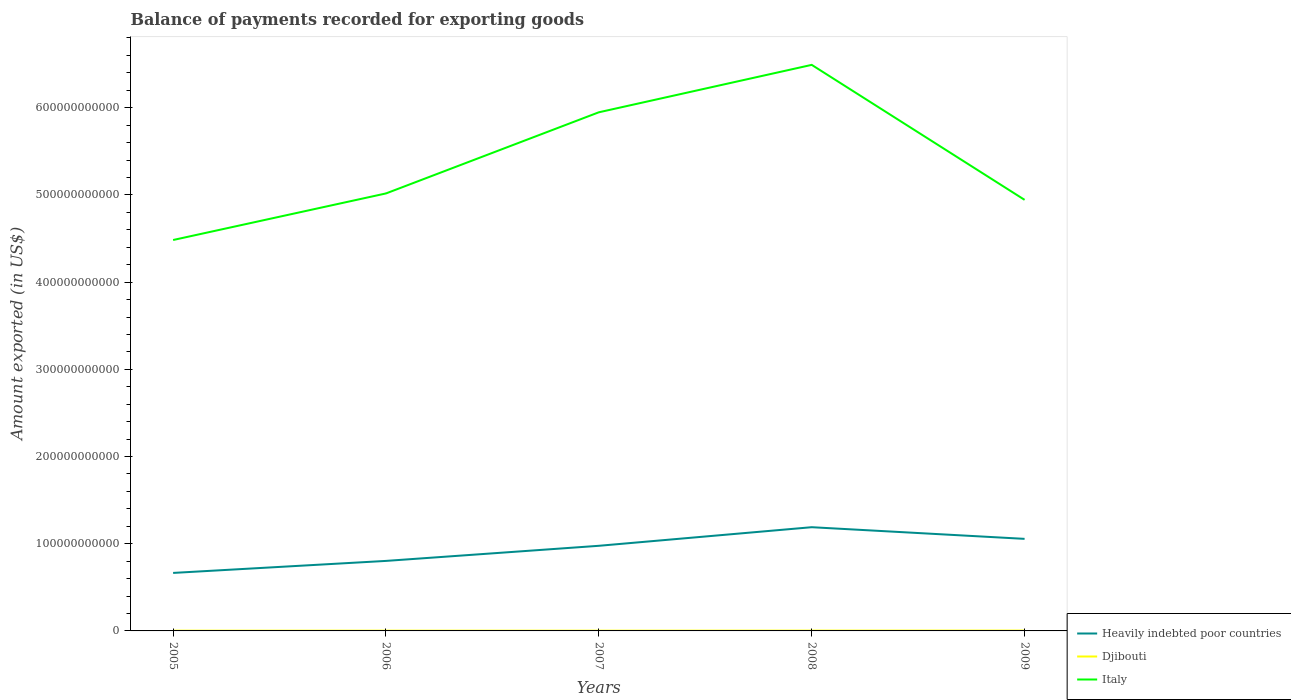Across all years, what is the maximum amount exported in Italy?
Give a very brief answer. 4.48e+11. In which year was the amount exported in Italy maximum?
Keep it short and to the point. 2005. What is the total amount exported in Italy in the graph?
Provide a short and direct response. 1.55e+11. What is the difference between the highest and the second highest amount exported in Italy?
Give a very brief answer. 2.01e+11. What is the difference between the highest and the lowest amount exported in Heavily indebted poor countries?
Keep it short and to the point. 3. Is the amount exported in Djibouti strictly greater than the amount exported in Italy over the years?
Keep it short and to the point. Yes. How many lines are there?
Your answer should be compact. 3. What is the difference between two consecutive major ticks on the Y-axis?
Provide a short and direct response. 1.00e+11. Does the graph contain any zero values?
Give a very brief answer. No. Does the graph contain grids?
Your answer should be very brief. No. Where does the legend appear in the graph?
Make the answer very short. Bottom right. How many legend labels are there?
Provide a short and direct response. 3. What is the title of the graph?
Offer a very short reply. Balance of payments recorded for exporting goods. Does "Isle of Man" appear as one of the legend labels in the graph?
Your answer should be very brief. No. What is the label or title of the X-axis?
Your answer should be compact. Years. What is the label or title of the Y-axis?
Your answer should be very brief. Amount exported (in US$). What is the Amount exported (in US$) of Heavily indebted poor countries in 2005?
Provide a succinct answer. 6.65e+1. What is the Amount exported (in US$) of Djibouti in 2005?
Provide a short and direct response. 2.88e+08. What is the Amount exported (in US$) of Italy in 2005?
Keep it short and to the point. 4.48e+11. What is the Amount exported (in US$) of Heavily indebted poor countries in 2006?
Make the answer very short. 8.03e+1. What is the Amount exported (in US$) in Djibouti in 2006?
Offer a very short reply. 3.07e+08. What is the Amount exported (in US$) in Italy in 2006?
Offer a terse response. 5.02e+11. What is the Amount exported (in US$) of Heavily indebted poor countries in 2007?
Ensure brevity in your answer.  9.76e+1. What is the Amount exported (in US$) in Djibouti in 2007?
Make the answer very short. 2.94e+08. What is the Amount exported (in US$) in Italy in 2007?
Offer a very short reply. 5.95e+11. What is the Amount exported (in US$) in Heavily indebted poor countries in 2008?
Your answer should be compact. 1.19e+11. What is the Amount exported (in US$) in Djibouti in 2008?
Your answer should be compact. 3.53e+08. What is the Amount exported (in US$) in Italy in 2008?
Offer a terse response. 6.49e+11. What is the Amount exported (in US$) of Heavily indebted poor countries in 2009?
Offer a very short reply. 1.06e+11. What is the Amount exported (in US$) of Djibouti in 2009?
Your response must be concise. 3.86e+08. What is the Amount exported (in US$) of Italy in 2009?
Your answer should be compact. 4.94e+11. Across all years, what is the maximum Amount exported (in US$) of Heavily indebted poor countries?
Offer a very short reply. 1.19e+11. Across all years, what is the maximum Amount exported (in US$) of Djibouti?
Your answer should be compact. 3.86e+08. Across all years, what is the maximum Amount exported (in US$) in Italy?
Ensure brevity in your answer.  6.49e+11. Across all years, what is the minimum Amount exported (in US$) in Heavily indebted poor countries?
Keep it short and to the point. 6.65e+1. Across all years, what is the minimum Amount exported (in US$) in Djibouti?
Your response must be concise. 2.88e+08. Across all years, what is the minimum Amount exported (in US$) in Italy?
Offer a very short reply. 4.48e+11. What is the total Amount exported (in US$) of Heavily indebted poor countries in the graph?
Ensure brevity in your answer.  4.69e+11. What is the total Amount exported (in US$) of Djibouti in the graph?
Your answer should be compact. 1.63e+09. What is the total Amount exported (in US$) of Italy in the graph?
Keep it short and to the point. 2.69e+12. What is the difference between the Amount exported (in US$) in Heavily indebted poor countries in 2005 and that in 2006?
Provide a succinct answer. -1.38e+1. What is the difference between the Amount exported (in US$) of Djibouti in 2005 and that in 2006?
Ensure brevity in your answer.  -1.88e+07. What is the difference between the Amount exported (in US$) in Italy in 2005 and that in 2006?
Offer a very short reply. -5.34e+1. What is the difference between the Amount exported (in US$) in Heavily indebted poor countries in 2005 and that in 2007?
Your answer should be very brief. -3.11e+1. What is the difference between the Amount exported (in US$) of Djibouti in 2005 and that in 2007?
Ensure brevity in your answer.  -6.30e+06. What is the difference between the Amount exported (in US$) of Italy in 2005 and that in 2007?
Your answer should be very brief. -1.46e+11. What is the difference between the Amount exported (in US$) in Heavily indebted poor countries in 2005 and that in 2008?
Make the answer very short. -5.24e+1. What is the difference between the Amount exported (in US$) in Djibouti in 2005 and that in 2008?
Offer a terse response. -6.48e+07. What is the difference between the Amount exported (in US$) of Italy in 2005 and that in 2008?
Your response must be concise. -2.01e+11. What is the difference between the Amount exported (in US$) of Heavily indebted poor countries in 2005 and that in 2009?
Keep it short and to the point. -3.91e+1. What is the difference between the Amount exported (in US$) in Djibouti in 2005 and that in 2009?
Your response must be concise. -9.79e+07. What is the difference between the Amount exported (in US$) in Italy in 2005 and that in 2009?
Offer a very short reply. -4.61e+1. What is the difference between the Amount exported (in US$) in Heavily indebted poor countries in 2006 and that in 2007?
Provide a succinct answer. -1.73e+1. What is the difference between the Amount exported (in US$) of Djibouti in 2006 and that in 2007?
Offer a very short reply. 1.25e+07. What is the difference between the Amount exported (in US$) in Italy in 2006 and that in 2007?
Ensure brevity in your answer.  -9.31e+1. What is the difference between the Amount exported (in US$) of Heavily indebted poor countries in 2006 and that in 2008?
Offer a very short reply. -3.87e+1. What is the difference between the Amount exported (in US$) of Djibouti in 2006 and that in 2008?
Your answer should be compact. -4.61e+07. What is the difference between the Amount exported (in US$) of Italy in 2006 and that in 2008?
Make the answer very short. -1.47e+11. What is the difference between the Amount exported (in US$) in Heavily indebted poor countries in 2006 and that in 2009?
Provide a short and direct response. -2.53e+1. What is the difference between the Amount exported (in US$) in Djibouti in 2006 and that in 2009?
Your response must be concise. -7.92e+07. What is the difference between the Amount exported (in US$) of Italy in 2006 and that in 2009?
Your response must be concise. 7.35e+09. What is the difference between the Amount exported (in US$) in Heavily indebted poor countries in 2007 and that in 2008?
Give a very brief answer. -2.13e+1. What is the difference between the Amount exported (in US$) of Djibouti in 2007 and that in 2008?
Keep it short and to the point. -5.85e+07. What is the difference between the Amount exported (in US$) of Italy in 2007 and that in 2008?
Your response must be concise. -5.44e+1. What is the difference between the Amount exported (in US$) of Heavily indebted poor countries in 2007 and that in 2009?
Provide a succinct answer. -7.96e+09. What is the difference between the Amount exported (in US$) of Djibouti in 2007 and that in 2009?
Make the answer very short. -9.16e+07. What is the difference between the Amount exported (in US$) of Italy in 2007 and that in 2009?
Your answer should be compact. 1.00e+11. What is the difference between the Amount exported (in US$) in Heavily indebted poor countries in 2008 and that in 2009?
Your answer should be very brief. 1.34e+1. What is the difference between the Amount exported (in US$) in Djibouti in 2008 and that in 2009?
Make the answer very short. -3.31e+07. What is the difference between the Amount exported (in US$) in Italy in 2008 and that in 2009?
Keep it short and to the point. 1.55e+11. What is the difference between the Amount exported (in US$) of Heavily indebted poor countries in 2005 and the Amount exported (in US$) of Djibouti in 2006?
Give a very brief answer. 6.62e+1. What is the difference between the Amount exported (in US$) in Heavily indebted poor countries in 2005 and the Amount exported (in US$) in Italy in 2006?
Offer a terse response. -4.35e+11. What is the difference between the Amount exported (in US$) of Djibouti in 2005 and the Amount exported (in US$) of Italy in 2006?
Your response must be concise. -5.01e+11. What is the difference between the Amount exported (in US$) in Heavily indebted poor countries in 2005 and the Amount exported (in US$) in Djibouti in 2007?
Offer a terse response. 6.62e+1. What is the difference between the Amount exported (in US$) of Heavily indebted poor countries in 2005 and the Amount exported (in US$) of Italy in 2007?
Offer a very short reply. -5.28e+11. What is the difference between the Amount exported (in US$) of Djibouti in 2005 and the Amount exported (in US$) of Italy in 2007?
Your answer should be very brief. -5.94e+11. What is the difference between the Amount exported (in US$) in Heavily indebted poor countries in 2005 and the Amount exported (in US$) in Djibouti in 2008?
Keep it short and to the point. 6.62e+1. What is the difference between the Amount exported (in US$) in Heavily indebted poor countries in 2005 and the Amount exported (in US$) in Italy in 2008?
Offer a very short reply. -5.83e+11. What is the difference between the Amount exported (in US$) of Djibouti in 2005 and the Amount exported (in US$) of Italy in 2008?
Offer a terse response. -6.49e+11. What is the difference between the Amount exported (in US$) of Heavily indebted poor countries in 2005 and the Amount exported (in US$) of Djibouti in 2009?
Offer a terse response. 6.61e+1. What is the difference between the Amount exported (in US$) of Heavily indebted poor countries in 2005 and the Amount exported (in US$) of Italy in 2009?
Keep it short and to the point. -4.28e+11. What is the difference between the Amount exported (in US$) in Djibouti in 2005 and the Amount exported (in US$) in Italy in 2009?
Ensure brevity in your answer.  -4.94e+11. What is the difference between the Amount exported (in US$) in Heavily indebted poor countries in 2006 and the Amount exported (in US$) in Djibouti in 2007?
Your answer should be very brief. 8.00e+1. What is the difference between the Amount exported (in US$) of Heavily indebted poor countries in 2006 and the Amount exported (in US$) of Italy in 2007?
Keep it short and to the point. -5.14e+11. What is the difference between the Amount exported (in US$) in Djibouti in 2006 and the Amount exported (in US$) in Italy in 2007?
Your response must be concise. -5.94e+11. What is the difference between the Amount exported (in US$) in Heavily indebted poor countries in 2006 and the Amount exported (in US$) in Djibouti in 2008?
Keep it short and to the point. 7.99e+1. What is the difference between the Amount exported (in US$) of Heavily indebted poor countries in 2006 and the Amount exported (in US$) of Italy in 2008?
Your response must be concise. -5.69e+11. What is the difference between the Amount exported (in US$) of Djibouti in 2006 and the Amount exported (in US$) of Italy in 2008?
Your answer should be compact. -6.49e+11. What is the difference between the Amount exported (in US$) of Heavily indebted poor countries in 2006 and the Amount exported (in US$) of Djibouti in 2009?
Ensure brevity in your answer.  7.99e+1. What is the difference between the Amount exported (in US$) of Heavily indebted poor countries in 2006 and the Amount exported (in US$) of Italy in 2009?
Your response must be concise. -4.14e+11. What is the difference between the Amount exported (in US$) of Djibouti in 2006 and the Amount exported (in US$) of Italy in 2009?
Offer a terse response. -4.94e+11. What is the difference between the Amount exported (in US$) of Heavily indebted poor countries in 2007 and the Amount exported (in US$) of Djibouti in 2008?
Ensure brevity in your answer.  9.73e+1. What is the difference between the Amount exported (in US$) of Heavily indebted poor countries in 2007 and the Amount exported (in US$) of Italy in 2008?
Provide a succinct answer. -5.52e+11. What is the difference between the Amount exported (in US$) in Djibouti in 2007 and the Amount exported (in US$) in Italy in 2008?
Your answer should be compact. -6.49e+11. What is the difference between the Amount exported (in US$) of Heavily indebted poor countries in 2007 and the Amount exported (in US$) of Djibouti in 2009?
Your answer should be compact. 9.72e+1. What is the difference between the Amount exported (in US$) of Heavily indebted poor countries in 2007 and the Amount exported (in US$) of Italy in 2009?
Your answer should be compact. -3.97e+11. What is the difference between the Amount exported (in US$) in Djibouti in 2007 and the Amount exported (in US$) in Italy in 2009?
Your answer should be compact. -4.94e+11. What is the difference between the Amount exported (in US$) of Heavily indebted poor countries in 2008 and the Amount exported (in US$) of Djibouti in 2009?
Offer a very short reply. 1.19e+11. What is the difference between the Amount exported (in US$) in Heavily indebted poor countries in 2008 and the Amount exported (in US$) in Italy in 2009?
Your answer should be compact. -3.75e+11. What is the difference between the Amount exported (in US$) in Djibouti in 2008 and the Amount exported (in US$) in Italy in 2009?
Your answer should be compact. -4.94e+11. What is the average Amount exported (in US$) of Heavily indebted poor countries per year?
Keep it short and to the point. 9.38e+1. What is the average Amount exported (in US$) of Djibouti per year?
Provide a succinct answer. 3.25e+08. What is the average Amount exported (in US$) in Italy per year?
Ensure brevity in your answer.  5.38e+11. In the year 2005, what is the difference between the Amount exported (in US$) in Heavily indebted poor countries and Amount exported (in US$) in Djibouti?
Provide a succinct answer. 6.62e+1. In the year 2005, what is the difference between the Amount exported (in US$) in Heavily indebted poor countries and Amount exported (in US$) in Italy?
Provide a short and direct response. -3.82e+11. In the year 2005, what is the difference between the Amount exported (in US$) of Djibouti and Amount exported (in US$) of Italy?
Make the answer very short. -4.48e+11. In the year 2006, what is the difference between the Amount exported (in US$) of Heavily indebted poor countries and Amount exported (in US$) of Djibouti?
Provide a short and direct response. 8.00e+1. In the year 2006, what is the difference between the Amount exported (in US$) in Heavily indebted poor countries and Amount exported (in US$) in Italy?
Your answer should be compact. -4.21e+11. In the year 2006, what is the difference between the Amount exported (in US$) in Djibouti and Amount exported (in US$) in Italy?
Provide a succinct answer. -5.01e+11. In the year 2007, what is the difference between the Amount exported (in US$) of Heavily indebted poor countries and Amount exported (in US$) of Djibouti?
Offer a terse response. 9.73e+1. In the year 2007, what is the difference between the Amount exported (in US$) of Heavily indebted poor countries and Amount exported (in US$) of Italy?
Offer a very short reply. -4.97e+11. In the year 2007, what is the difference between the Amount exported (in US$) of Djibouti and Amount exported (in US$) of Italy?
Ensure brevity in your answer.  -5.94e+11. In the year 2008, what is the difference between the Amount exported (in US$) in Heavily indebted poor countries and Amount exported (in US$) in Djibouti?
Make the answer very short. 1.19e+11. In the year 2008, what is the difference between the Amount exported (in US$) of Heavily indebted poor countries and Amount exported (in US$) of Italy?
Provide a succinct answer. -5.30e+11. In the year 2008, what is the difference between the Amount exported (in US$) in Djibouti and Amount exported (in US$) in Italy?
Your answer should be compact. -6.49e+11. In the year 2009, what is the difference between the Amount exported (in US$) in Heavily indebted poor countries and Amount exported (in US$) in Djibouti?
Offer a very short reply. 1.05e+11. In the year 2009, what is the difference between the Amount exported (in US$) in Heavily indebted poor countries and Amount exported (in US$) in Italy?
Provide a succinct answer. -3.89e+11. In the year 2009, what is the difference between the Amount exported (in US$) of Djibouti and Amount exported (in US$) of Italy?
Your answer should be very brief. -4.94e+11. What is the ratio of the Amount exported (in US$) in Heavily indebted poor countries in 2005 to that in 2006?
Make the answer very short. 0.83. What is the ratio of the Amount exported (in US$) in Djibouti in 2005 to that in 2006?
Make the answer very short. 0.94. What is the ratio of the Amount exported (in US$) of Italy in 2005 to that in 2006?
Make the answer very short. 0.89. What is the ratio of the Amount exported (in US$) of Heavily indebted poor countries in 2005 to that in 2007?
Offer a terse response. 0.68. What is the ratio of the Amount exported (in US$) of Djibouti in 2005 to that in 2007?
Your answer should be very brief. 0.98. What is the ratio of the Amount exported (in US$) of Italy in 2005 to that in 2007?
Make the answer very short. 0.75. What is the ratio of the Amount exported (in US$) in Heavily indebted poor countries in 2005 to that in 2008?
Your answer should be very brief. 0.56. What is the ratio of the Amount exported (in US$) of Djibouti in 2005 to that in 2008?
Ensure brevity in your answer.  0.82. What is the ratio of the Amount exported (in US$) of Italy in 2005 to that in 2008?
Give a very brief answer. 0.69. What is the ratio of the Amount exported (in US$) in Heavily indebted poor countries in 2005 to that in 2009?
Your answer should be compact. 0.63. What is the ratio of the Amount exported (in US$) in Djibouti in 2005 to that in 2009?
Your answer should be compact. 0.75. What is the ratio of the Amount exported (in US$) of Italy in 2005 to that in 2009?
Offer a very short reply. 0.91. What is the ratio of the Amount exported (in US$) in Heavily indebted poor countries in 2006 to that in 2007?
Your response must be concise. 0.82. What is the ratio of the Amount exported (in US$) of Djibouti in 2006 to that in 2007?
Offer a very short reply. 1.04. What is the ratio of the Amount exported (in US$) in Italy in 2006 to that in 2007?
Your answer should be compact. 0.84. What is the ratio of the Amount exported (in US$) in Heavily indebted poor countries in 2006 to that in 2008?
Provide a short and direct response. 0.68. What is the ratio of the Amount exported (in US$) of Djibouti in 2006 to that in 2008?
Provide a succinct answer. 0.87. What is the ratio of the Amount exported (in US$) in Italy in 2006 to that in 2008?
Offer a very short reply. 0.77. What is the ratio of the Amount exported (in US$) in Heavily indebted poor countries in 2006 to that in 2009?
Your response must be concise. 0.76. What is the ratio of the Amount exported (in US$) of Djibouti in 2006 to that in 2009?
Provide a succinct answer. 0.79. What is the ratio of the Amount exported (in US$) in Italy in 2006 to that in 2009?
Offer a very short reply. 1.01. What is the ratio of the Amount exported (in US$) of Heavily indebted poor countries in 2007 to that in 2008?
Provide a short and direct response. 0.82. What is the ratio of the Amount exported (in US$) of Djibouti in 2007 to that in 2008?
Your answer should be very brief. 0.83. What is the ratio of the Amount exported (in US$) in Italy in 2007 to that in 2008?
Ensure brevity in your answer.  0.92. What is the ratio of the Amount exported (in US$) of Heavily indebted poor countries in 2007 to that in 2009?
Your answer should be very brief. 0.92. What is the ratio of the Amount exported (in US$) of Djibouti in 2007 to that in 2009?
Give a very brief answer. 0.76. What is the ratio of the Amount exported (in US$) of Italy in 2007 to that in 2009?
Make the answer very short. 1.2. What is the ratio of the Amount exported (in US$) in Heavily indebted poor countries in 2008 to that in 2009?
Your response must be concise. 1.13. What is the ratio of the Amount exported (in US$) of Djibouti in 2008 to that in 2009?
Ensure brevity in your answer.  0.91. What is the ratio of the Amount exported (in US$) in Italy in 2008 to that in 2009?
Provide a succinct answer. 1.31. What is the difference between the highest and the second highest Amount exported (in US$) of Heavily indebted poor countries?
Offer a very short reply. 1.34e+1. What is the difference between the highest and the second highest Amount exported (in US$) of Djibouti?
Offer a terse response. 3.31e+07. What is the difference between the highest and the second highest Amount exported (in US$) of Italy?
Offer a terse response. 5.44e+1. What is the difference between the highest and the lowest Amount exported (in US$) of Heavily indebted poor countries?
Your response must be concise. 5.24e+1. What is the difference between the highest and the lowest Amount exported (in US$) of Djibouti?
Your response must be concise. 9.79e+07. What is the difference between the highest and the lowest Amount exported (in US$) of Italy?
Ensure brevity in your answer.  2.01e+11. 